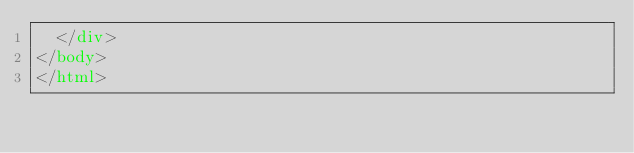<code> <loc_0><loc_0><loc_500><loc_500><_HTML_>  </div>
</body>
</html></code> 